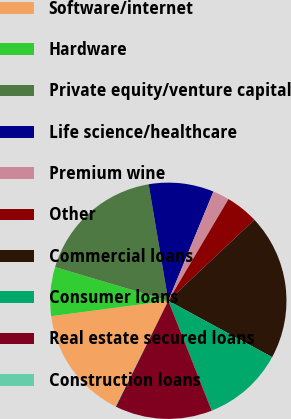Convert chart to OTSL. <chart><loc_0><loc_0><loc_500><loc_500><pie_chart><fcel>Software/internet<fcel>Hardware<fcel>Private equity/venture capital<fcel>Life science/healthcare<fcel>Premium wine<fcel>Other<fcel>Commercial loans<fcel>Consumer loans<fcel>Real estate secured loans<fcel>Construction loans<nl><fcel>15.52%<fcel>6.69%<fcel>17.73%<fcel>8.9%<fcel>2.27%<fcel>4.48%<fcel>19.93%<fcel>11.1%<fcel>13.31%<fcel>0.07%<nl></chart> 